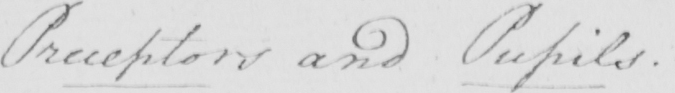What text is written in this handwritten line? Preceptors and Pupils . 